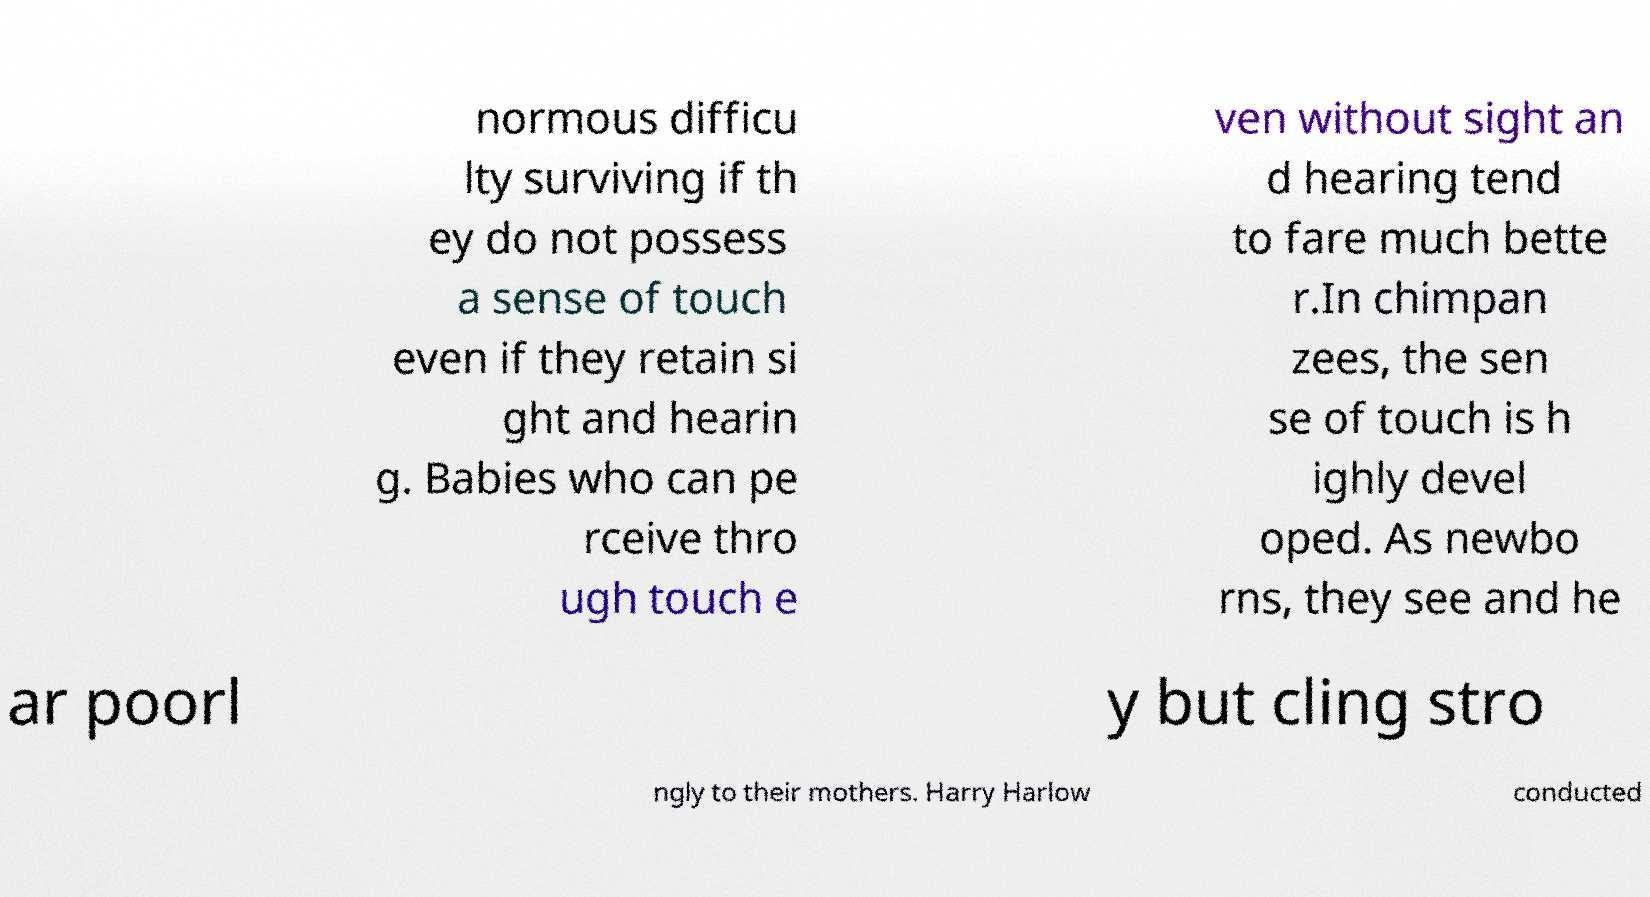I need the written content from this picture converted into text. Can you do that? normous difficu lty surviving if th ey do not possess a sense of touch even if they retain si ght and hearin g. Babies who can pe rceive thro ugh touch e ven without sight an d hearing tend to fare much bette r.In chimpan zees, the sen se of touch is h ighly devel oped. As newbo rns, they see and he ar poorl y but cling stro ngly to their mothers. Harry Harlow conducted 